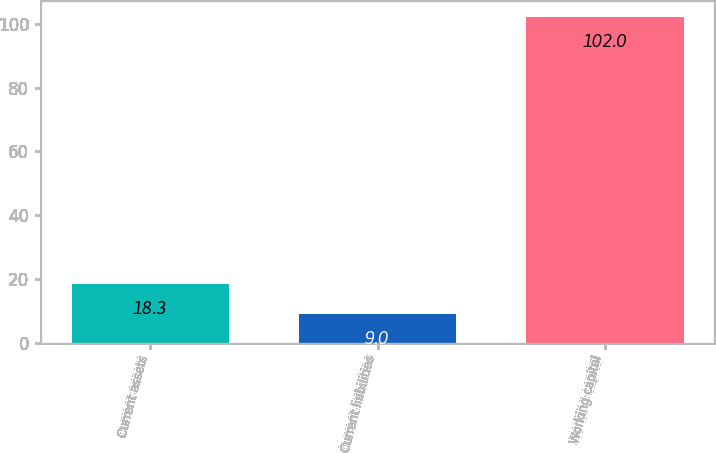Convert chart to OTSL. <chart><loc_0><loc_0><loc_500><loc_500><bar_chart><fcel>Current assets<fcel>Current liabilities<fcel>Working capital<nl><fcel>18.3<fcel>9<fcel>102<nl></chart> 